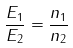Convert formula to latex. <formula><loc_0><loc_0><loc_500><loc_500>\frac { E _ { 1 } } { E _ { 2 } } = \frac { n _ { 1 } } { n _ { 2 } }</formula> 